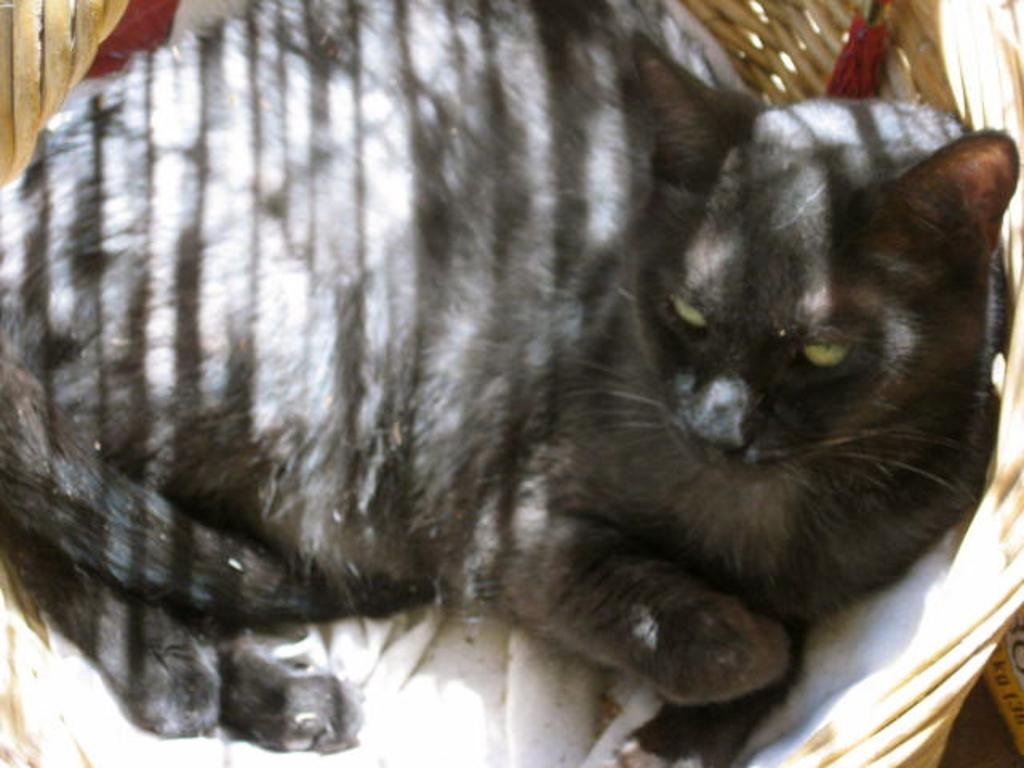What type of animal is in the image? There is a black cat in the image. Where is the cat located? The cat is in a basket. Can you describe the object in the right side bottom corner of the image? Unfortunately, the provided facts do not mention any details about the object in the right side bottom corner of the image. How many chairs are visible in the image? There are no chairs visible in the image. What type of building is shown in the background of the image? There is no building shown in the background of the image. 